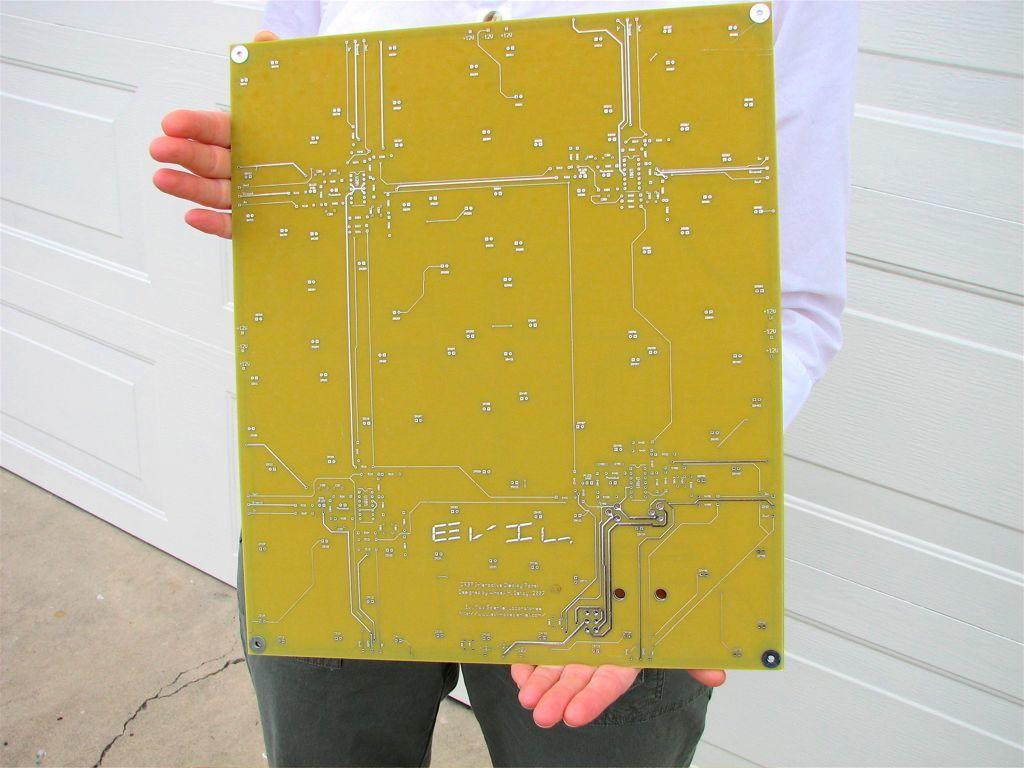What is the person in the image doing? The person is standing in the image. What is the person wearing? The person is wearing a white color shirt. What object is the person holding? The person is holding a circuit board. What can be seen in the background of the image? There is a white color wooden wall in the background of the image. What type of digestion is the person experiencing in the image? There is no indication of digestion in the image; it only shows a person standing and holding a circuit board. 